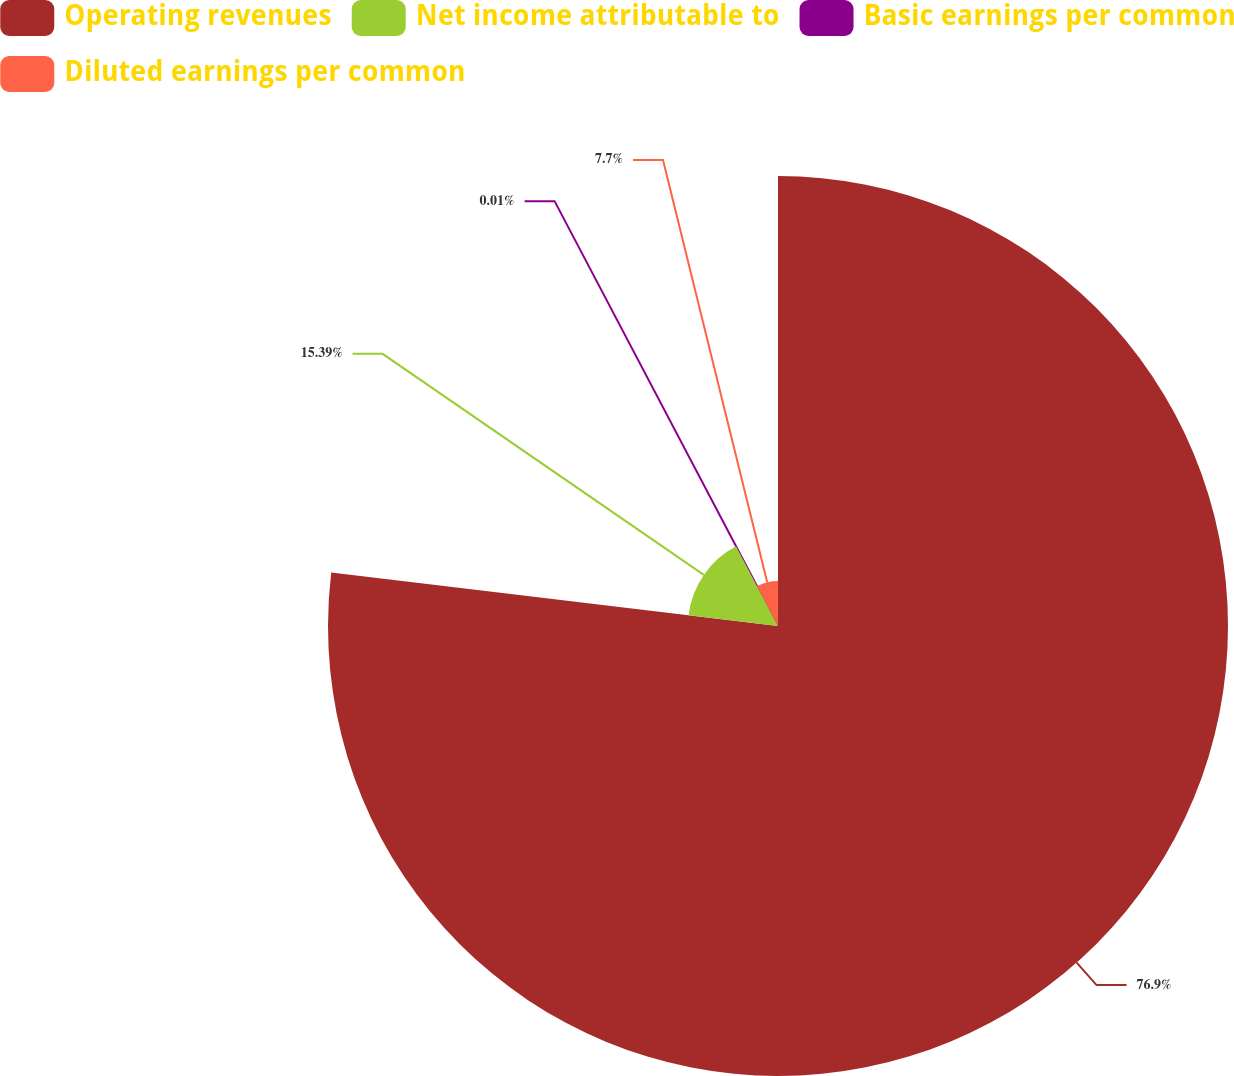Convert chart to OTSL. <chart><loc_0><loc_0><loc_500><loc_500><pie_chart><fcel>Operating revenues<fcel>Net income attributable to<fcel>Basic earnings per common<fcel>Diluted earnings per common<nl><fcel>76.9%<fcel>15.39%<fcel>0.01%<fcel>7.7%<nl></chart> 